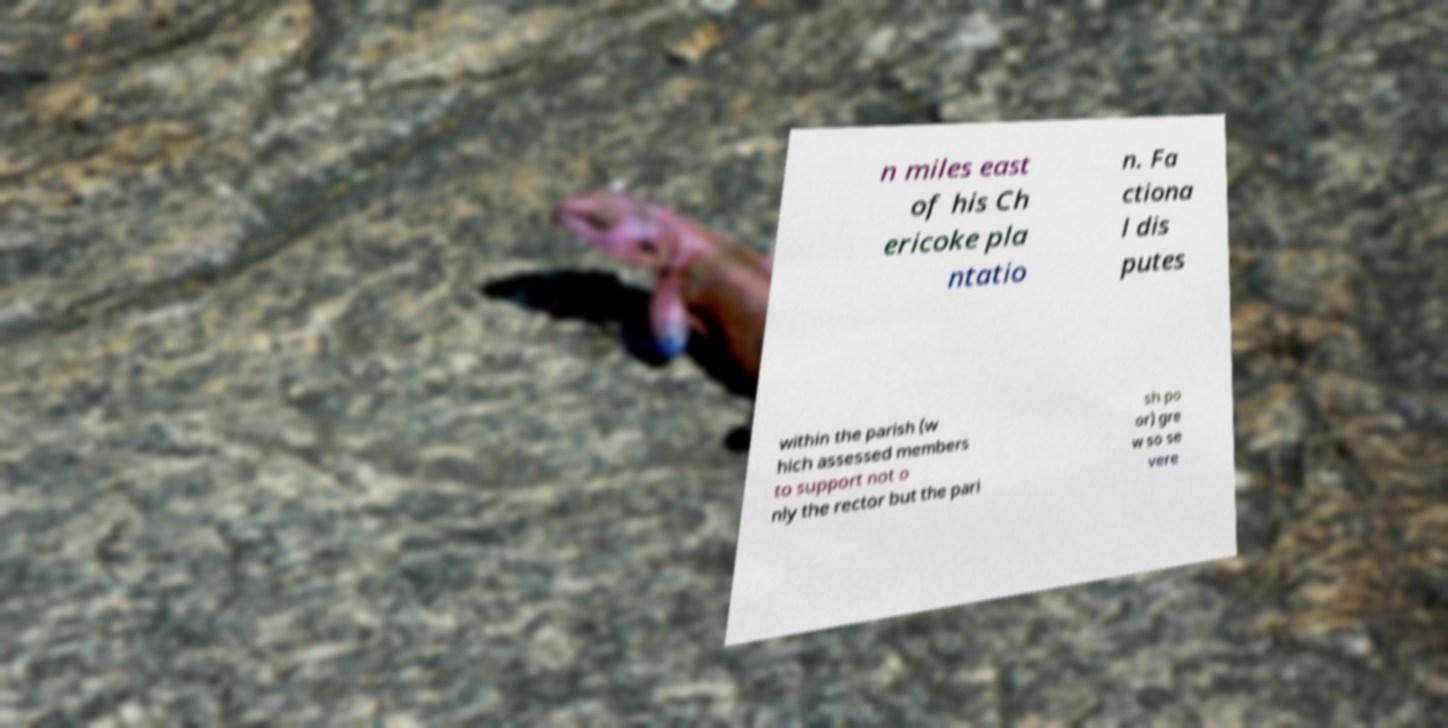I need the written content from this picture converted into text. Can you do that? n miles east of his Ch ericoke pla ntatio n. Fa ctiona l dis putes within the parish (w hich assessed members to support not o nly the rector but the pari sh po or) gre w so se vere 